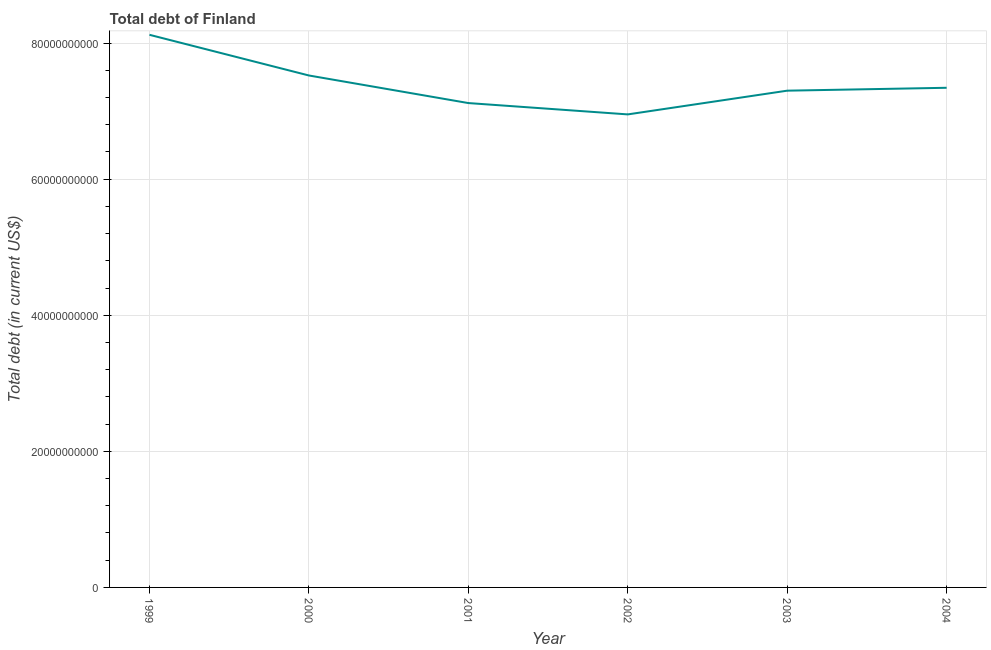What is the total debt in 2003?
Ensure brevity in your answer.  7.30e+1. Across all years, what is the maximum total debt?
Offer a very short reply. 8.12e+1. Across all years, what is the minimum total debt?
Provide a short and direct response. 6.95e+1. What is the sum of the total debt?
Provide a short and direct response. 4.44e+11. What is the difference between the total debt in 2000 and 2003?
Keep it short and to the point. 2.23e+09. What is the average total debt per year?
Give a very brief answer. 7.39e+1. What is the median total debt?
Keep it short and to the point. 7.32e+1. Do a majority of the years between 1999 and 2003 (inclusive) have total debt greater than 56000000000 US$?
Offer a very short reply. Yes. What is the ratio of the total debt in 2000 to that in 2004?
Make the answer very short. 1.02. Is the total debt in 1999 less than that in 2002?
Keep it short and to the point. No. Is the difference between the total debt in 1999 and 2000 greater than the difference between any two years?
Ensure brevity in your answer.  No. What is the difference between the highest and the second highest total debt?
Provide a succinct answer. 5.98e+09. Is the sum of the total debt in 2000 and 2004 greater than the maximum total debt across all years?
Your answer should be compact. Yes. What is the difference between the highest and the lowest total debt?
Keep it short and to the point. 1.17e+1. Does the total debt monotonically increase over the years?
Provide a succinct answer. No. How many lines are there?
Your response must be concise. 1. What is the difference between two consecutive major ticks on the Y-axis?
Your answer should be very brief. 2.00e+1. Are the values on the major ticks of Y-axis written in scientific E-notation?
Your response must be concise. No. Does the graph contain grids?
Keep it short and to the point. Yes. What is the title of the graph?
Ensure brevity in your answer.  Total debt of Finland. What is the label or title of the X-axis?
Offer a terse response. Year. What is the label or title of the Y-axis?
Give a very brief answer. Total debt (in current US$). What is the Total debt (in current US$) in 1999?
Your answer should be compact. 8.12e+1. What is the Total debt (in current US$) in 2000?
Your answer should be very brief. 7.52e+1. What is the Total debt (in current US$) in 2001?
Ensure brevity in your answer.  7.12e+1. What is the Total debt (in current US$) of 2002?
Give a very brief answer. 6.95e+1. What is the Total debt (in current US$) of 2003?
Your answer should be very brief. 7.30e+1. What is the Total debt (in current US$) in 2004?
Your response must be concise. 7.34e+1. What is the difference between the Total debt (in current US$) in 1999 and 2000?
Keep it short and to the point. 5.98e+09. What is the difference between the Total debt (in current US$) in 1999 and 2001?
Make the answer very short. 1.00e+1. What is the difference between the Total debt (in current US$) in 1999 and 2002?
Provide a short and direct response. 1.17e+1. What is the difference between the Total debt (in current US$) in 1999 and 2003?
Offer a terse response. 8.21e+09. What is the difference between the Total debt (in current US$) in 1999 and 2004?
Make the answer very short. 7.79e+09. What is the difference between the Total debt (in current US$) in 2000 and 2001?
Offer a terse response. 4.05e+09. What is the difference between the Total debt (in current US$) in 2000 and 2002?
Keep it short and to the point. 5.72e+09. What is the difference between the Total debt (in current US$) in 2000 and 2003?
Your answer should be very brief. 2.23e+09. What is the difference between the Total debt (in current US$) in 2000 and 2004?
Make the answer very short. 1.81e+09. What is the difference between the Total debt (in current US$) in 2001 and 2002?
Provide a short and direct response. 1.67e+09. What is the difference between the Total debt (in current US$) in 2001 and 2003?
Your answer should be compact. -1.82e+09. What is the difference between the Total debt (in current US$) in 2001 and 2004?
Keep it short and to the point. -2.24e+09. What is the difference between the Total debt (in current US$) in 2002 and 2003?
Give a very brief answer. -3.49e+09. What is the difference between the Total debt (in current US$) in 2002 and 2004?
Provide a succinct answer. -3.91e+09. What is the difference between the Total debt (in current US$) in 2003 and 2004?
Make the answer very short. -4.24e+08. What is the ratio of the Total debt (in current US$) in 1999 to that in 2000?
Your answer should be compact. 1.08. What is the ratio of the Total debt (in current US$) in 1999 to that in 2001?
Your response must be concise. 1.14. What is the ratio of the Total debt (in current US$) in 1999 to that in 2002?
Your answer should be compact. 1.17. What is the ratio of the Total debt (in current US$) in 1999 to that in 2003?
Provide a short and direct response. 1.11. What is the ratio of the Total debt (in current US$) in 1999 to that in 2004?
Your response must be concise. 1.11. What is the ratio of the Total debt (in current US$) in 2000 to that in 2001?
Provide a short and direct response. 1.06. What is the ratio of the Total debt (in current US$) in 2000 to that in 2002?
Your response must be concise. 1.08. What is the ratio of the Total debt (in current US$) in 2000 to that in 2003?
Your answer should be very brief. 1.03. What is the ratio of the Total debt (in current US$) in 2001 to that in 2002?
Your response must be concise. 1.02. What is the ratio of the Total debt (in current US$) in 2001 to that in 2004?
Provide a short and direct response. 0.97. What is the ratio of the Total debt (in current US$) in 2002 to that in 2004?
Offer a very short reply. 0.95. What is the ratio of the Total debt (in current US$) in 2003 to that in 2004?
Provide a short and direct response. 0.99. 